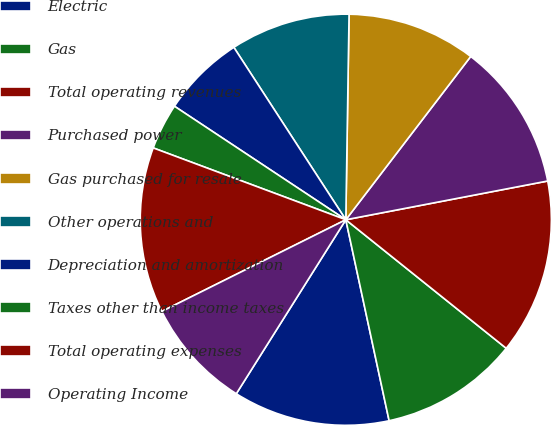Convert chart. <chart><loc_0><loc_0><loc_500><loc_500><pie_chart><fcel>Electric<fcel>Gas<fcel>Total operating revenues<fcel>Purchased power<fcel>Gas purchased for resale<fcel>Other operations and<fcel>Depreciation and amortization<fcel>Taxes other than income taxes<fcel>Total operating expenses<fcel>Operating Income<nl><fcel>12.32%<fcel>10.87%<fcel>13.77%<fcel>11.59%<fcel>10.14%<fcel>9.42%<fcel>6.52%<fcel>3.63%<fcel>13.04%<fcel>8.7%<nl></chart> 